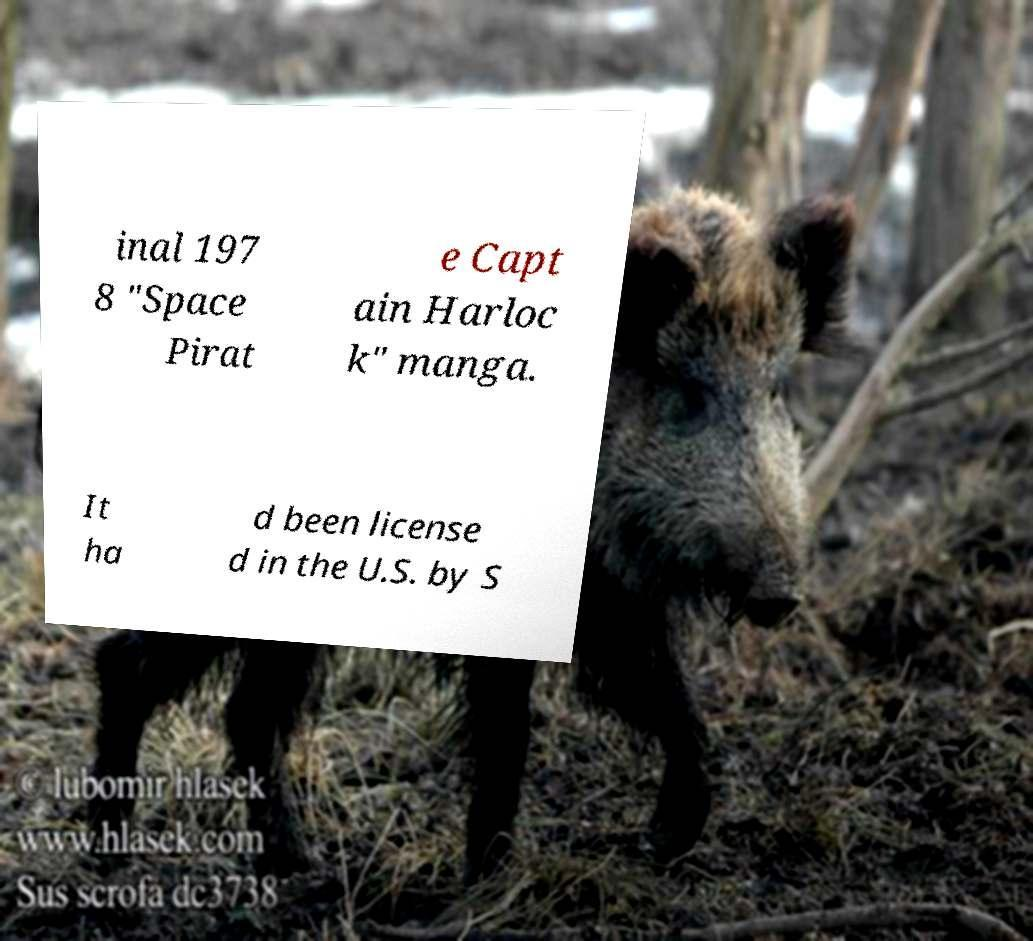Please read and relay the text visible in this image. What does it say? inal 197 8 "Space Pirat e Capt ain Harloc k" manga. It ha d been license d in the U.S. by S 